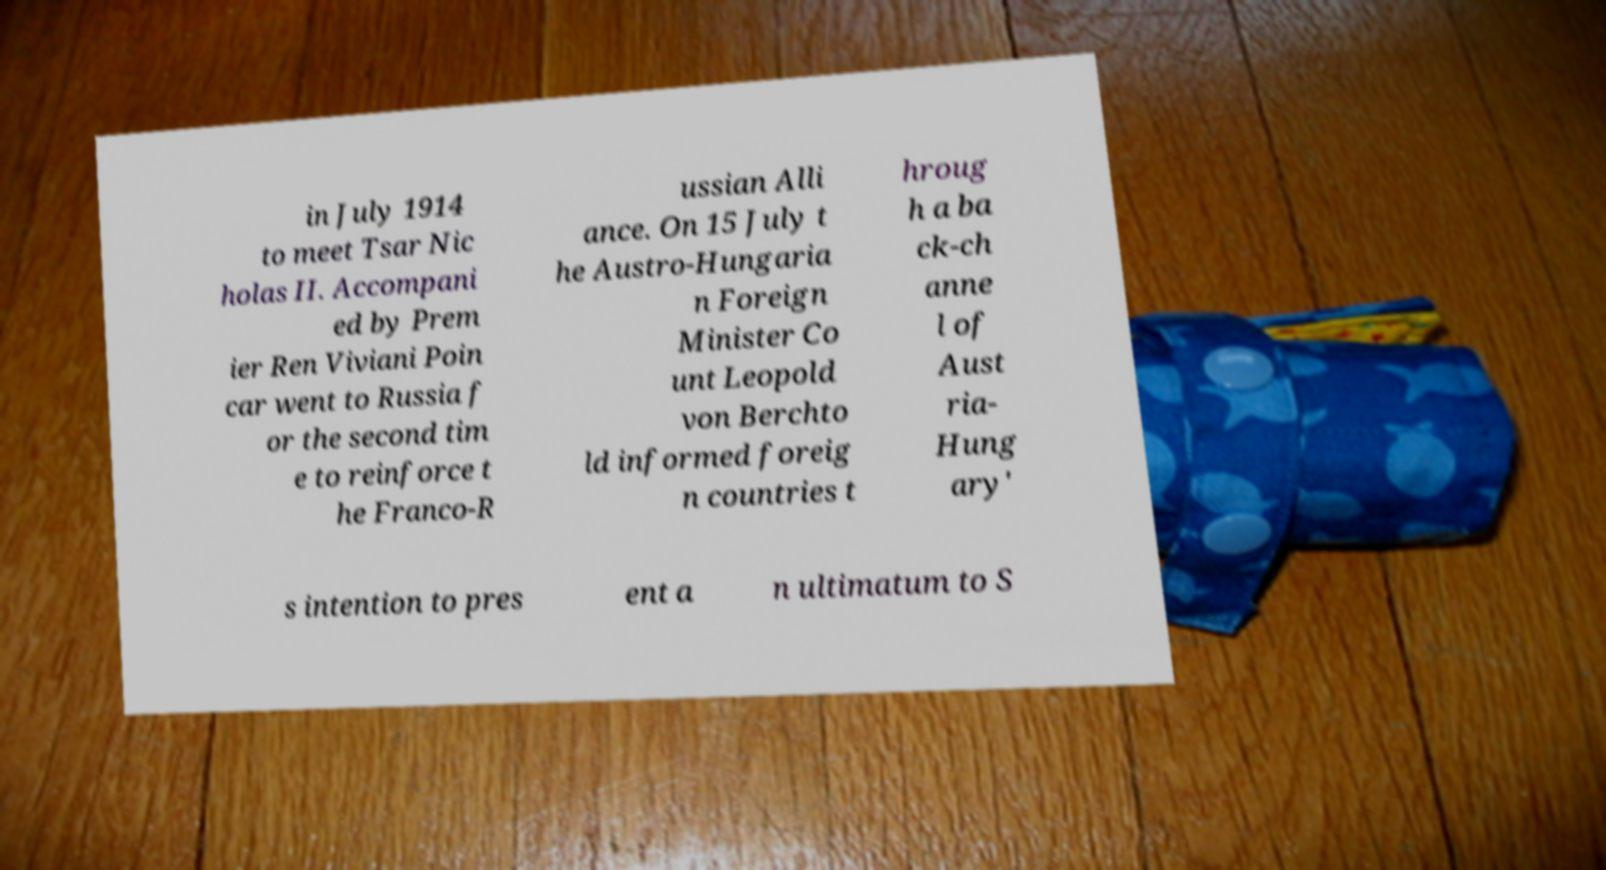Can you accurately transcribe the text from the provided image for me? in July 1914 to meet Tsar Nic holas II. Accompani ed by Prem ier Ren Viviani Poin car went to Russia f or the second tim e to reinforce t he Franco-R ussian Alli ance. On 15 July t he Austro-Hungaria n Foreign Minister Co unt Leopold von Berchto ld informed foreig n countries t hroug h a ba ck-ch anne l of Aust ria- Hung ary' s intention to pres ent a n ultimatum to S 